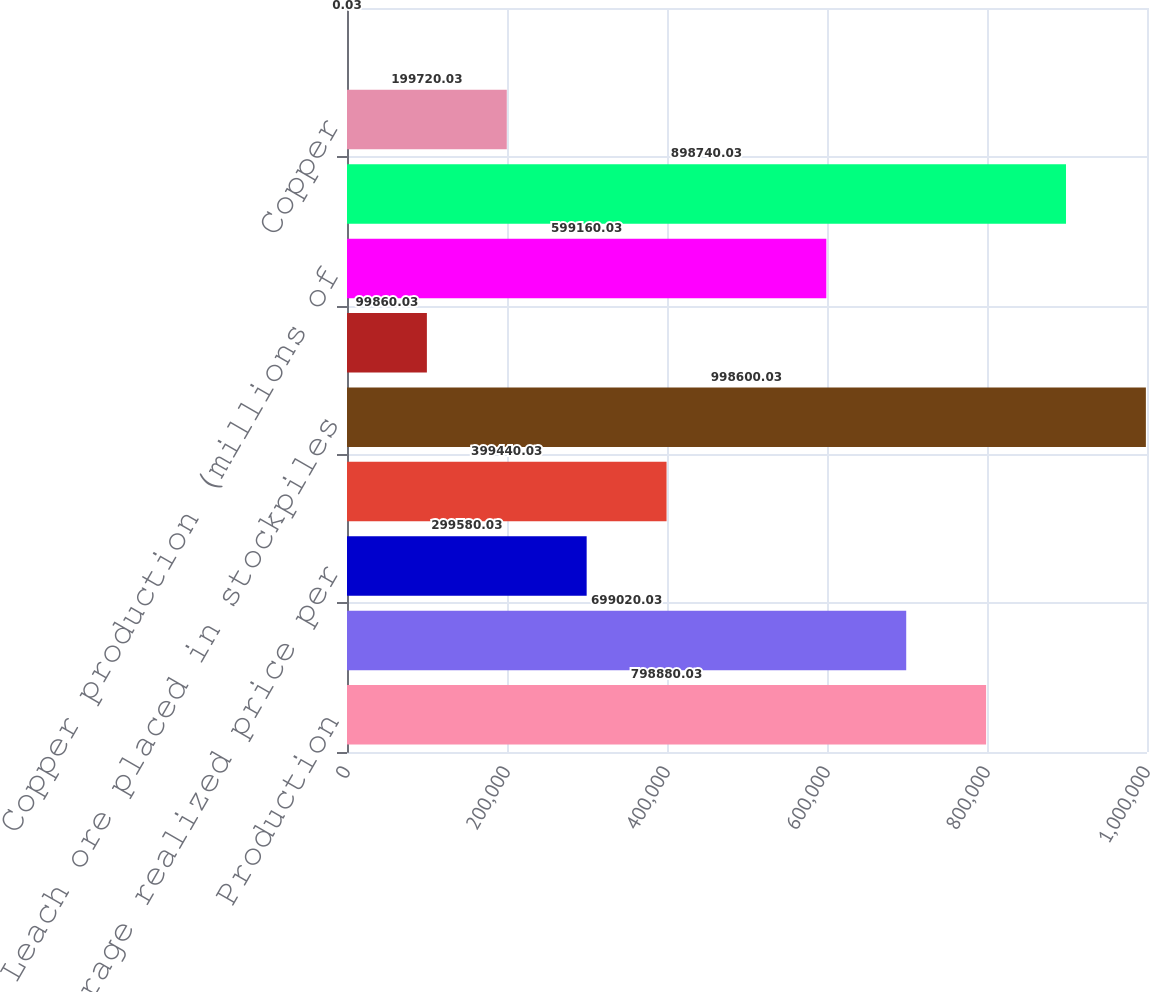Convert chart. <chart><loc_0><loc_0><loc_500><loc_500><bar_chart><fcel>Production<fcel>Sales excluding purchases<fcel>Average realized price per<fcel>Production^a<fcel>Leach ore placed in stockpiles<fcel>Average copper ore grade<fcel>Copper production (millions of<fcel>Ore milled (metric tons per<fcel>Copper<fcel>Molybdenum<nl><fcel>798880<fcel>699020<fcel>299580<fcel>399440<fcel>998600<fcel>99860<fcel>599160<fcel>898740<fcel>199720<fcel>0.03<nl></chart> 